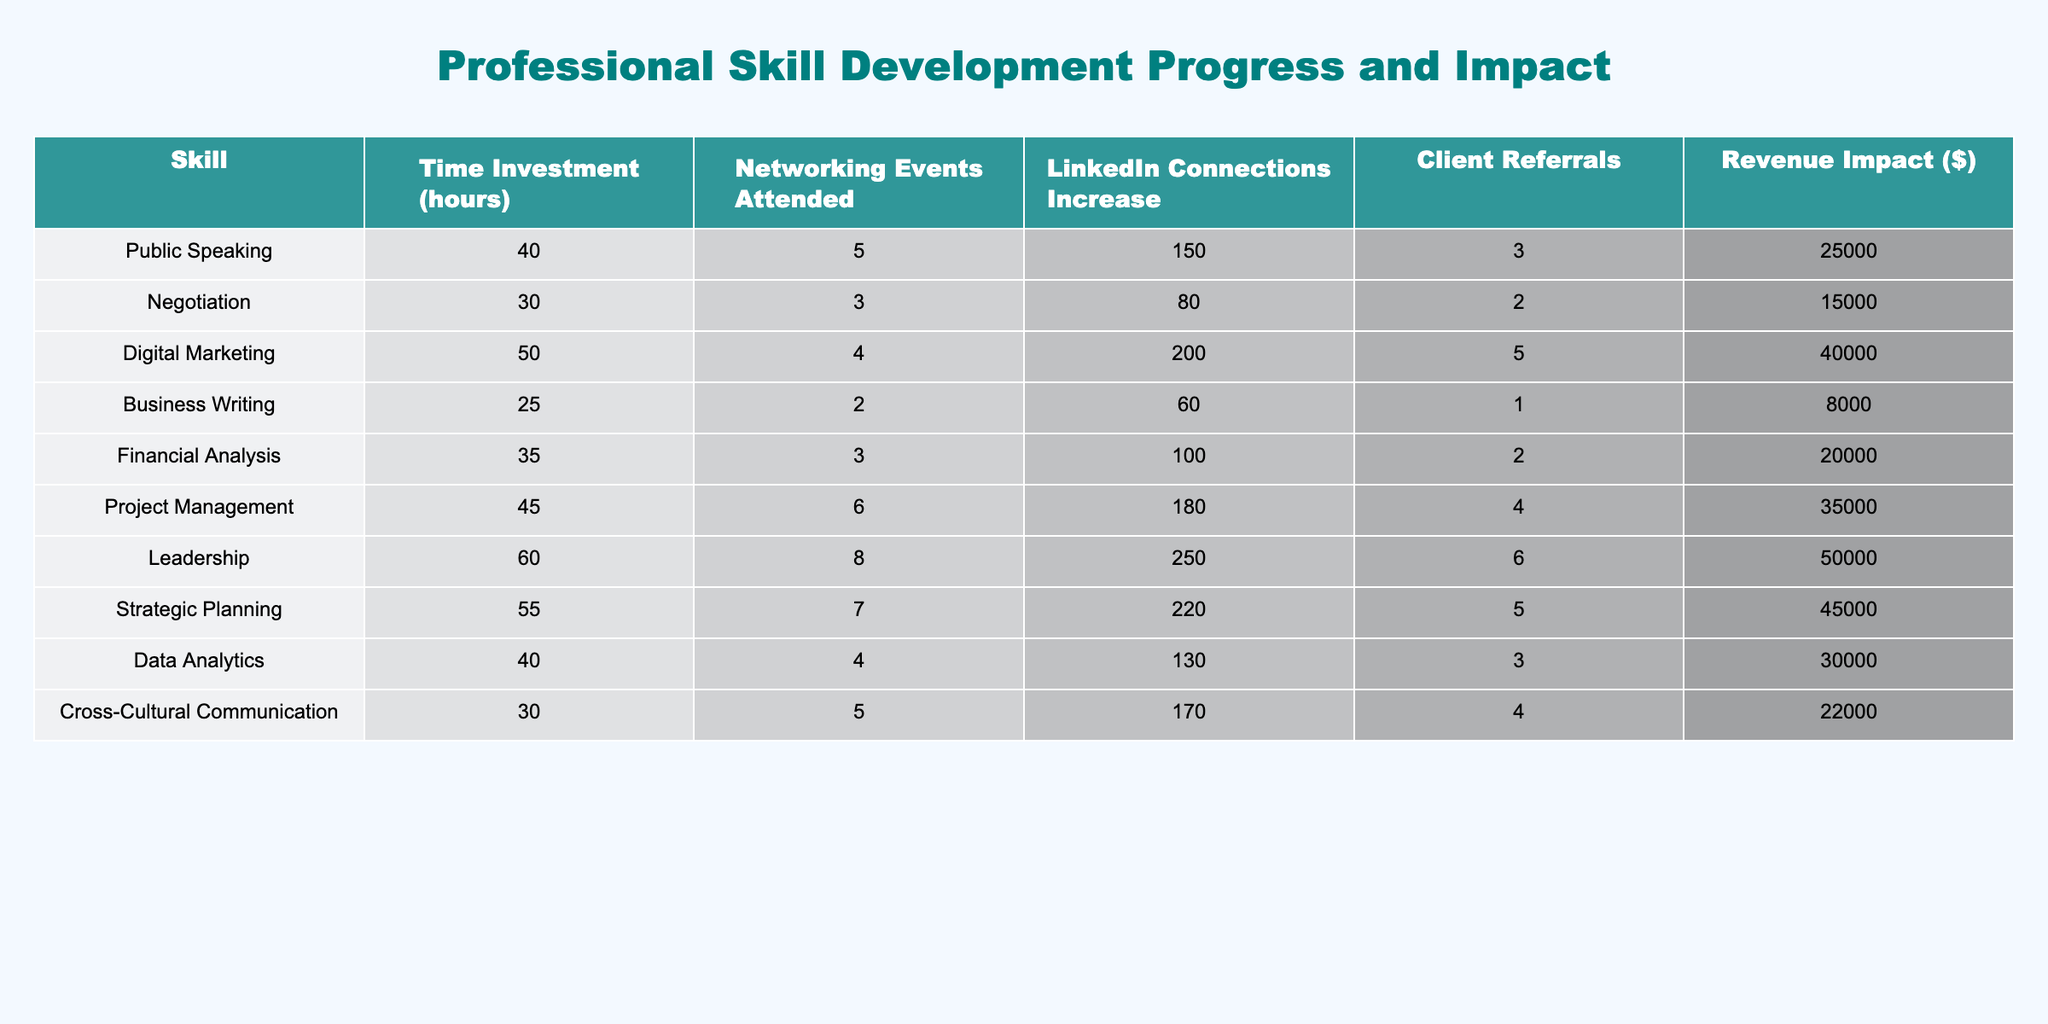What skill had the highest revenue impact? By looking at the revenue impact column, Leadership is the skill with the highest value at $50,000.
Answer: $50,000 How many hours were invested in Digital Marketing? The table directly shows that the time investment for Digital Marketing is 50 hours.
Answer: 50 hours Which skill had the least number of client referrals? By checking the client referrals column, Business Writing had the least with only 1 referral.
Answer: 1 referral What is the average time investment across all skills? First, sum the time investments: 40 + 30 + 50 + 25 + 35 + 45 + 60 + 55 + 40 + 30 =  420. Then divide by the number of skills (10): 420 / 10 = 42 hours.
Answer: 42 hours Did negotiation result in more than 2 client referrals? The table shows that negotiation had exactly 2 client referrals, which means the answer is no.
Answer: False Which skill had the highest increase in LinkedIn connections? Reviewing the LinkedIn connections column, Leadership yielded the highest increase at 250 connections.
Answer: 250 connections What is the total revenue impact from Project Management and Digital Marketing combined? First, find the revenue for each: Project Management is $35,000 and Digital Marketing is $40,000. Adding these gives $35,000 + $40,000 = $75,000.
Answer: $75,000 Is there a skill that required less than 30 hours of investment? By examining the time investment column, the lowest is Business Writing with 25 hours, so yes, such a skill exists.
Answer: True Which skill has the closest number of LinkedIn connections increase to the average across all skills? First, calculate the average increase in LinkedIn connections: (150 + 80 + 200 + 60 + 100 + 180 + 250 + 220 + 130 + 170) / 10 = 15. The closest values are Digital Marketing and Leadership with 200 and 250, respectively, which are both above the average.
Answer: Leadership (250 connections) What is the sum of networking events attended for all skills? By adding the networking events: 5 + 3 + 4 + 2 + 3 + 6 + 8 + 7 + 4 + 5 = 43 events total.
Answer: 43 events 